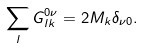<formula> <loc_0><loc_0><loc_500><loc_500>\sum _ { l } G _ { l k } ^ { 0 \nu } = 2 M _ { k } \delta _ { \nu 0 } .</formula> 